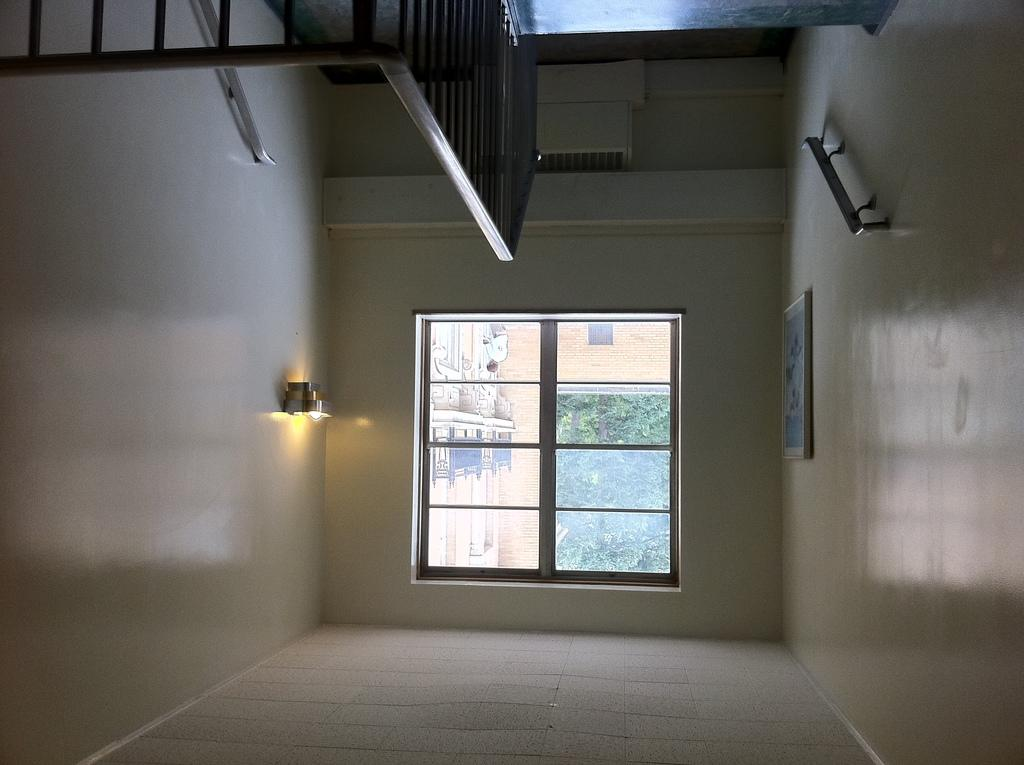What is the primary surface visible in the image? There is a floor in the image. What can be seen on the wall in the image? There is a frame on the wall in the image. What objects are present that resemble long, thin bars? There are rods in the image. Can you describe the source of illumination in the image? There is a light in the image. What type of window is visible in the image? There is a glass window in the image. What can be seen through the glass window? Green leaves and a wall are visible through the glass window. What type of punishment is being administered in the image? There is no indication of punishment in the image; it features a room with a floor, wall, window, and other elements. 